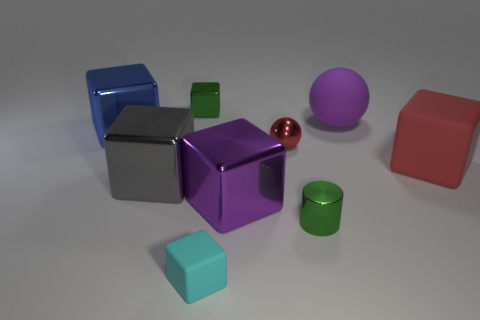There is a thing that is the same color as the tiny cylinder; what shape is it?
Ensure brevity in your answer.  Cube. How many shiny things have the same size as the gray cube?
Provide a succinct answer. 2. What is the size of the metallic ball that is the same color as the big rubber block?
Make the answer very short. Small. What number of things are either yellow balls or gray metallic objects left of the large purple cube?
Ensure brevity in your answer.  1. What is the color of the large object that is both in front of the tiny red metal ball and on the right side of the purple block?
Ensure brevity in your answer.  Red. Do the purple matte sphere and the green block have the same size?
Keep it short and to the point. No. The tiny block that is in front of the tiny metal block is what color?
Ensure brevity in your answer.  Cyan. Are there any big blocks of the same color as the big rubber ball?
Make the answer very short. Yes. The rubber object that is the same size as the purple rubber sphere is what color?
Your response must be concise. Red. Do the tiny cyan object and the red shiny thing have the same shape?
Offer a very short reply. No. 